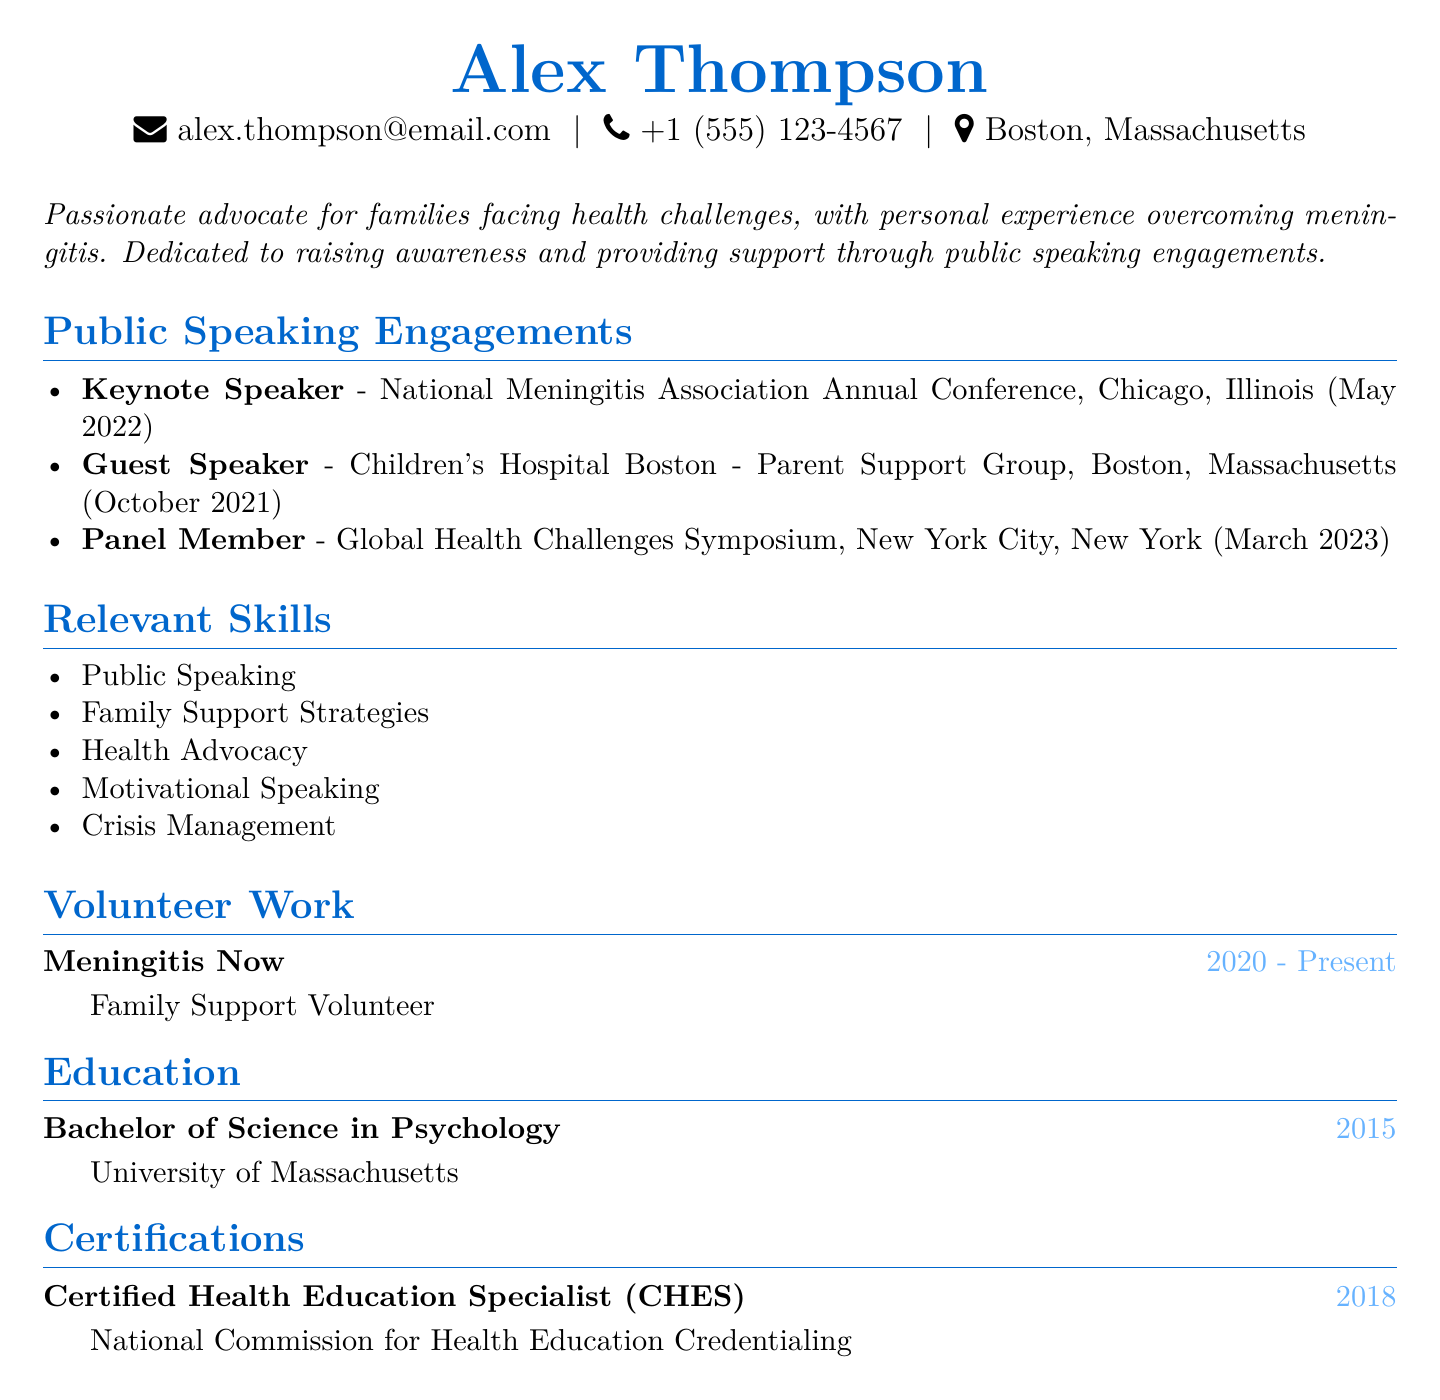What is the name of the individual? The name is found at the top of the document under the personal information section.
Answer: Alex Thompson What is the location of the keynote speaking engagement? The location is found in the public speaking engagements section, specifically for the keynote speaker event.
Answer: Chicago, Illinois In what year did Alex graduate? The graduation year is provided in the education section.
Answer: 2015 How many public speaking engagements are listed? The number of engagements can be found by counting the items in the public speaking engagements section.
Answer: 3 What organization is Alex volunteering for? The organization is mentioned in the volunteer work section.
Answer: Meningitis Now Which skill is related to health advocacy? This skill can be found in the relevant skills section, describing Alex's abilities.
Answer: Health Advocacy What role did Alex have at the Children's Hospital Boston event? The role is detailed under the public speaking engagements section.
Answer: Guest Speaker What certification did Alex obtain in 2018? The certification is listed under the certifications section specifically for the year 2018.
Answer: Certified Health Education Specialist (CHES) In which city was the Global Health Challenges Symposium held? The city is mentioned in the public speaking engagements section for this specific event.
Answer: New York City, New York 